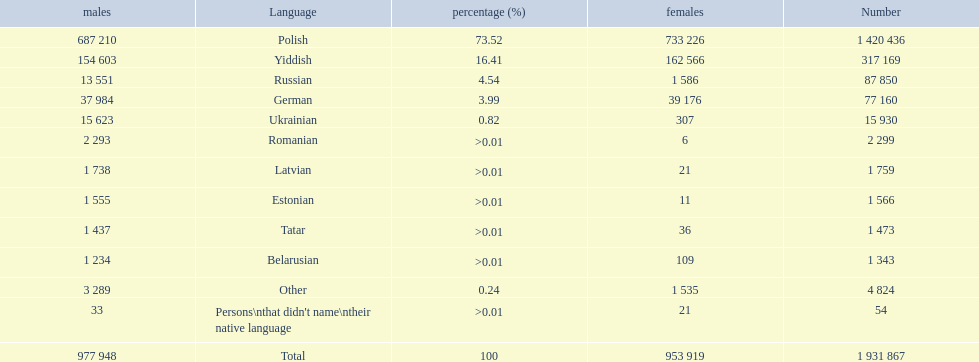What languages are spoken in the warsaw governorate? Polish, Yiddish, Russian, German, Ukrainian, Romanian, Latvian, Estonian, Tatar, Belarusian. Which are the top five languages? Polish, Yiddish, Russian, German, Ukrainian. Of those which is the 2nd most frequently spoken? Yiddish. 